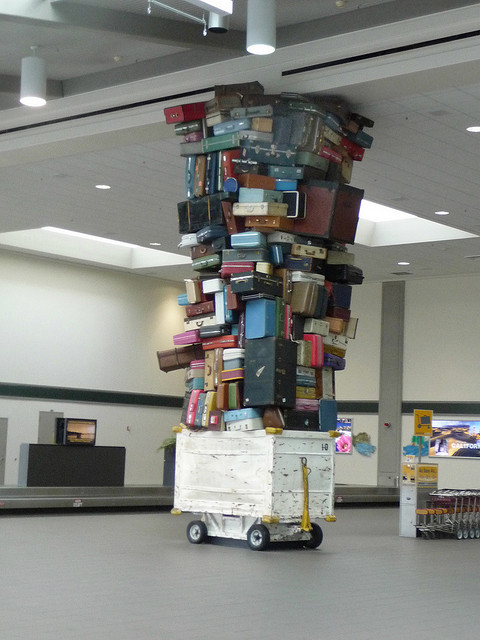What is the significance of this tower of luggage? This tower of suitcases could be an art installation, symbolizing the journeys and travels that take place through this location. It may represent a wide diversity of places, people, and experiences encapsulated in the various designs and conditions of the luggage. 